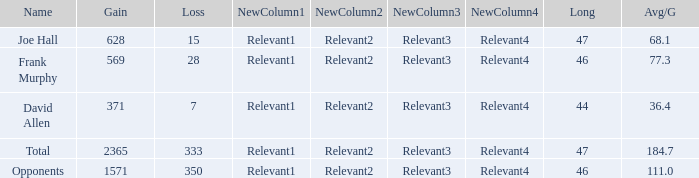Give me the full table as a dictionary. {'header': ['Name', 'Gain', 'Loss', 'NewColumn1', 'NewColumn2', 'NewColumn3', 'NewColumn4', 'Long', 'Avg/G'], 'rows': [['Joe Hall', '628', '15', 'Relevant1', 'Relevant2', 'Relevant3', 'Relevant4', '47', '68.1'], ['Frank Murphy', '569', '28', 'Relevant1', 'Relevant2', 'Relevant3', 'Relevant4', '46', '77.3'], ['David Allen', '371', '7', 'Relevant1', 'Relevant2', 'Relevant3', 'Relevant4', '44', '36.4'], ['Total', '2365', '333', 'Relevant1', 'Relevant2', 'Relevant3', 'Relevant4', '47', '184.7'], ['Opponents', '1571', '350', 'Relevant1', 'Relevant2', 'Relevant3', 'Relevant4', '46', '111.0']]} Which Avg/G has a Name of david allen, and a Gain larger than 371? None. 